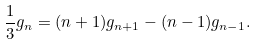<formula> <loc_0><loc_0><loc_500><loc_500>\frac { 1 } { 3 } g _ { n } = ( n + 1 ) g _ { n + 1 } - ( n - 1 ) g _ { n - 1 } .</formula> 